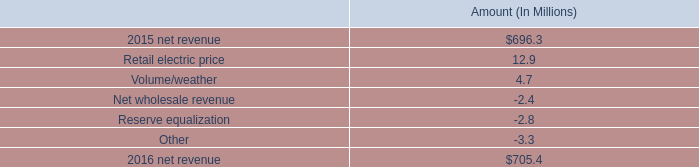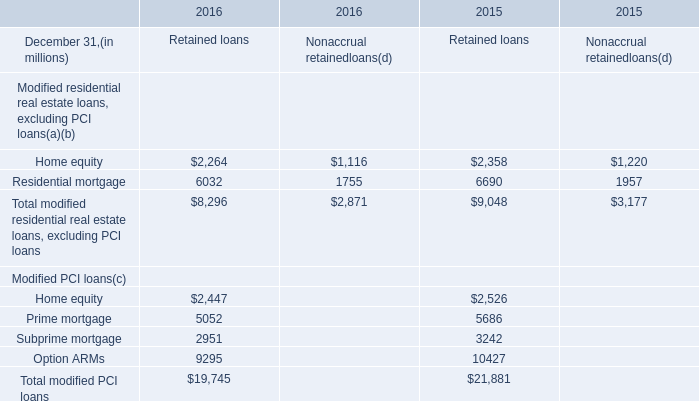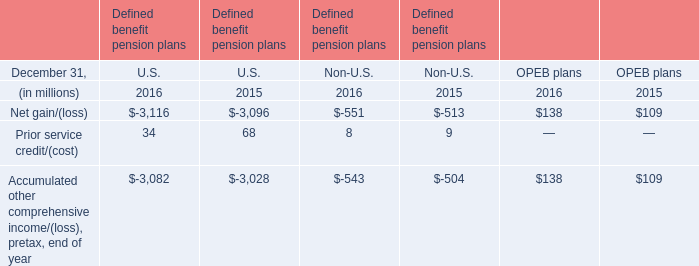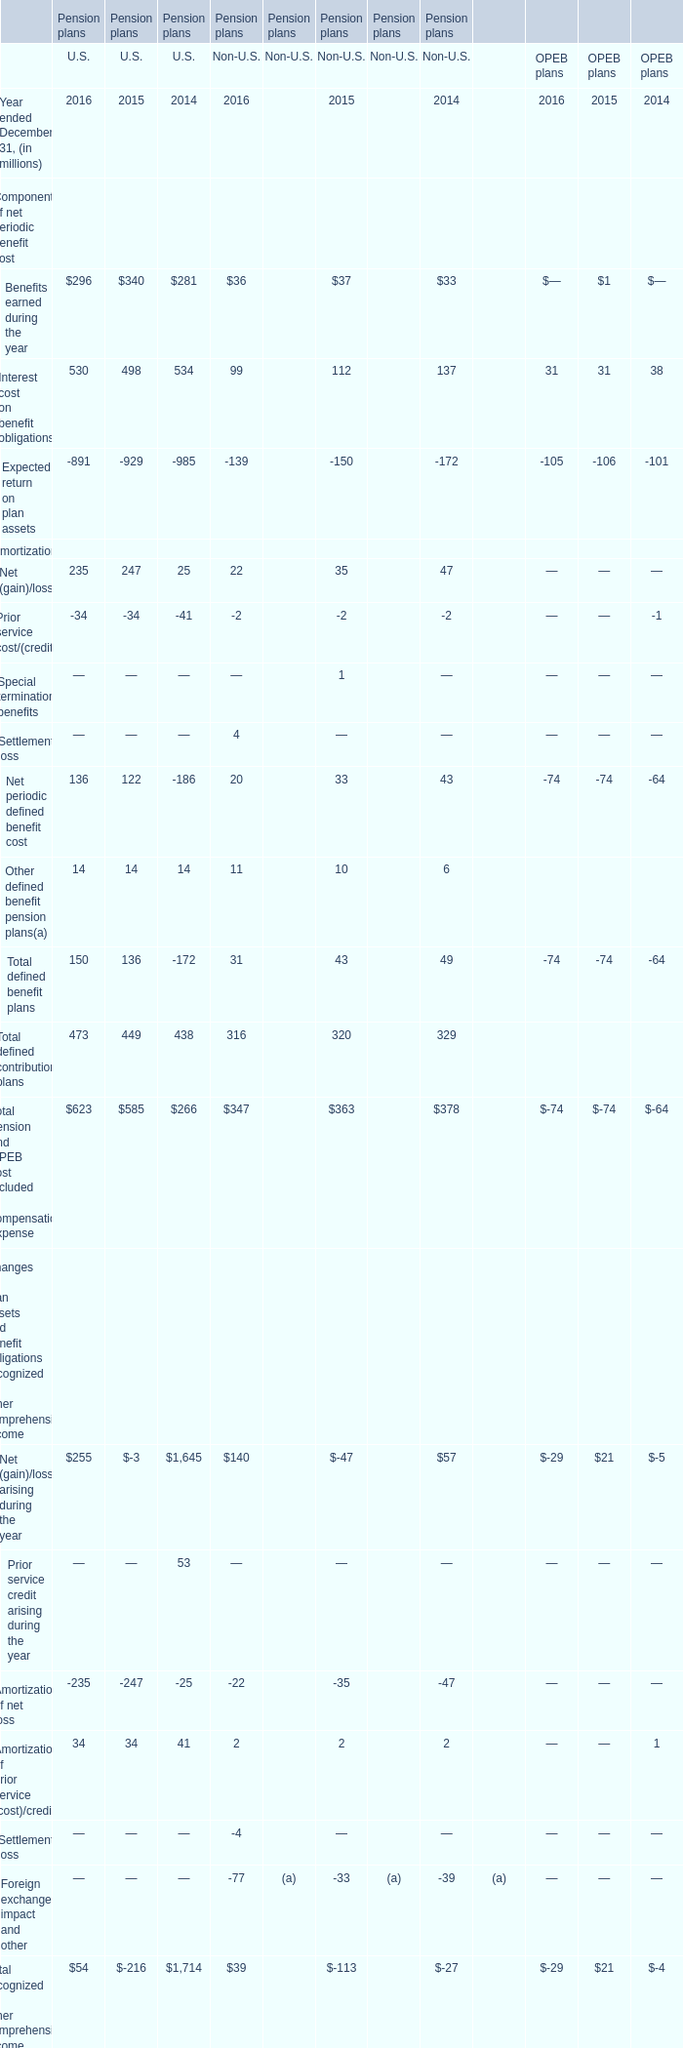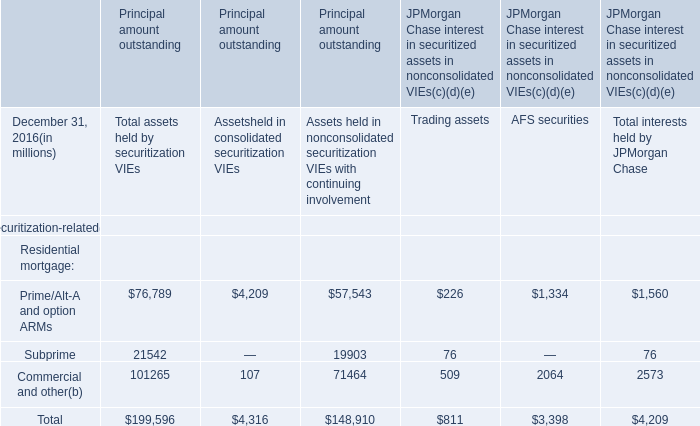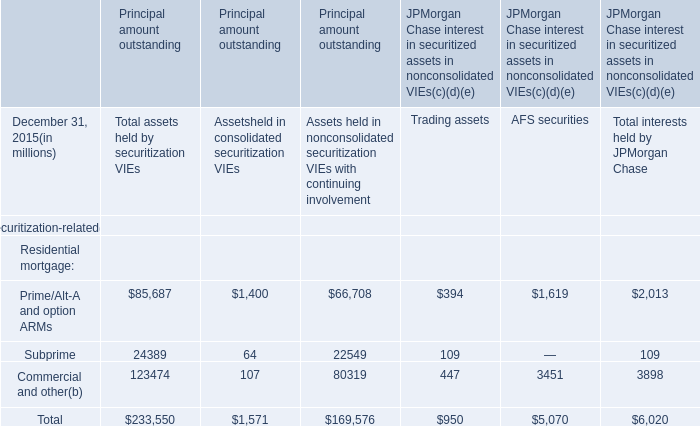In which year ended December 31 is Net (gain)/loss arising during the year for OPEB plans equal to 21 million? 
Answer: 2015. 